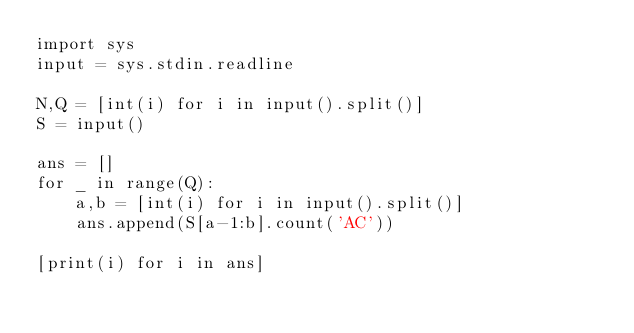<code> <loc_0><loc_0><loc_500><loc_500><_Python_>import sys
input = sys.stdin.readline

N,Q = [int(i) for i in input().split()]
S = input()

ans = []
for _ in range(Q):
    a,b = [int(i) for i in input().split()]
    ans.append(S[a-1:b].count('AC'))

[print(i) for i in ans]
</code> 